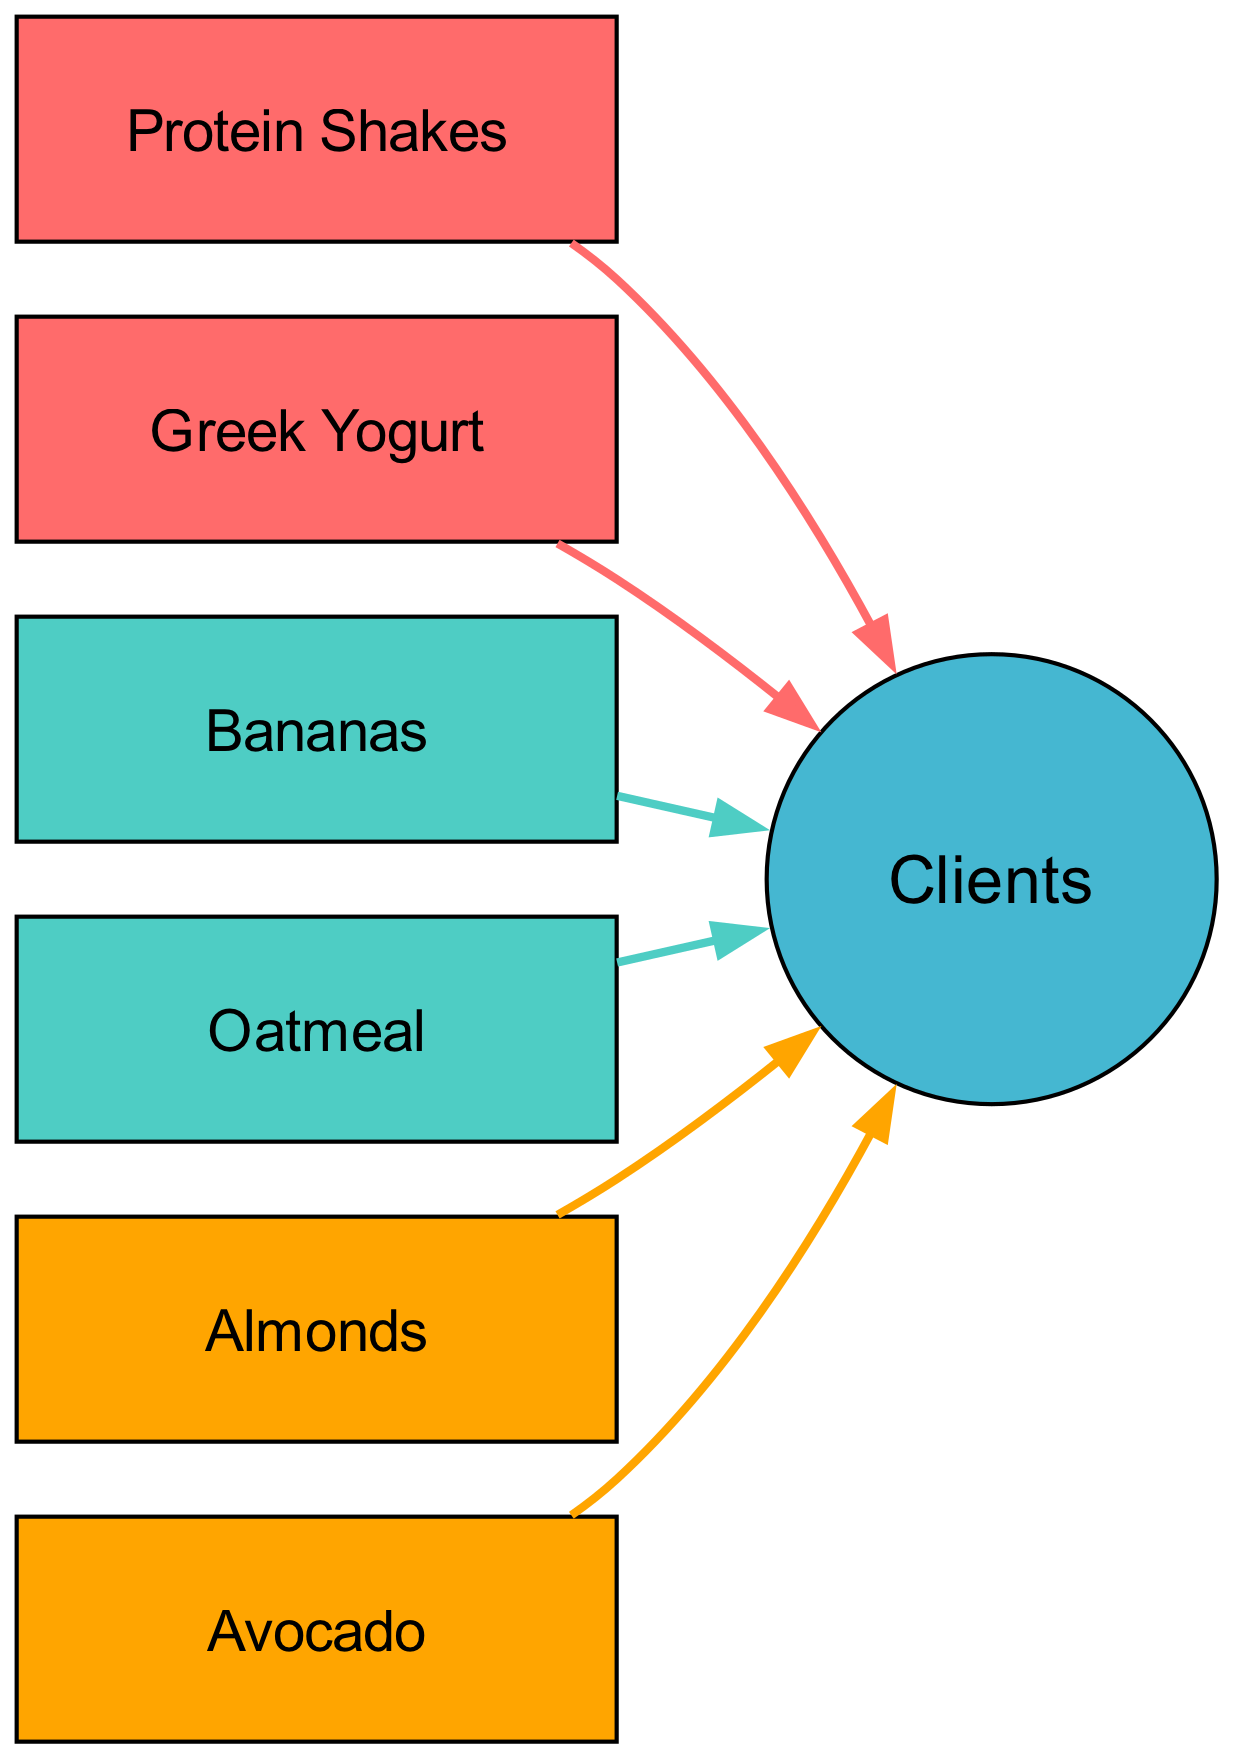What are the sources of protein in the diagram? The diagram lists "Protein Shakes" and "Greek Yogurt" as the sources of protein. By examining the nodes with the type labeled as 'Protein', these two items are identified.
Answer: Protein Shakes, Greek Yogurt How many sources of carbohydrate are shown in the diagram? The diagram shows two carbohydrate sources: "Bananas" and "Oatmeal". Counting the nodes with the type labeled as 'Carbohydrate', we find two distinct items.
Answer: 2 Which source has the highest distinction in terms of consumer connections? All sources point to "Clients", meaning they all share the same connection. Regardless of individual sources, they collectively connect to one consumer node. Thus, it would be sensible that all sources have equal consumer connections.
Answer: All sources What is the color representing fat sources in the diagram? The color assigned to fat sources in the diagram is orange, as defined in the color scheme where 'Fat' is linked to the color '#FFA500'.
Answer: Orange How many total sources can be seen in the diagram? The total count of sources in the diagram combines protein, carbohydrate, and fat sources. By enumerating all nodes under 'sources', we find six distinct items.
Answer: 6 What type of dietary component do "Bananas" and "Oatmeal" represent? Both "Bananas" and "Oatmeal" are classified under carbohydrates within the diagram. These are identified from their respective type labels.
Answer: Carbohydrate Is there any source that is exclusively fat? Yes, both "Almonds" and "Avocado" are classified as fat sources. Looking for exclusively fat sources means we focus on items labeled as 'Fat', and both of these fulfill that criterion.
Answer: Yes Which source contributes protein in liquid form? "Protein Shakes" is the only source that indicates a liquid form of protein. Among the protein sources, the diagram shows that only "Protein Shakes" is presented in this form.
Answer: Protein Shakes 